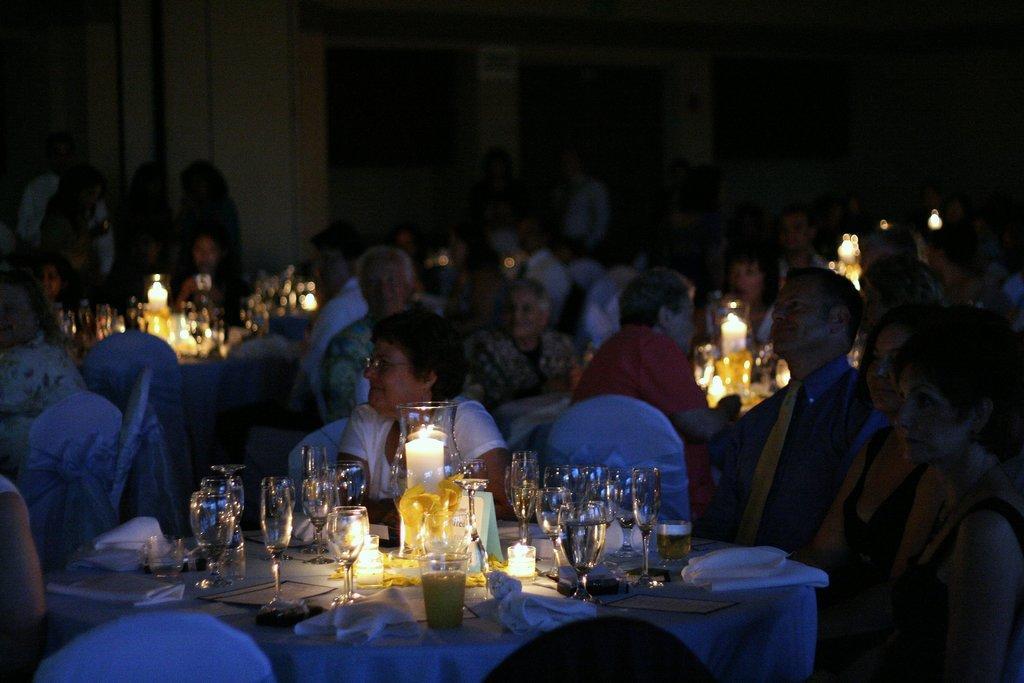Could you give a brief overview of what you see in this image? In this image there are people sitting on the chairs. In front of them there are tables. On top of tables there are glasses, candles and a few other objects. 